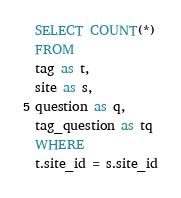Convert code to text. <code><loc_0><loc_0><loc_500><loc_500><_SQL_>SELECT COUNT(*)
FROM
tag as t,
site as s,
question as q,
tag_question as tq
WHERE
t.site_id = s.site_id</code> 